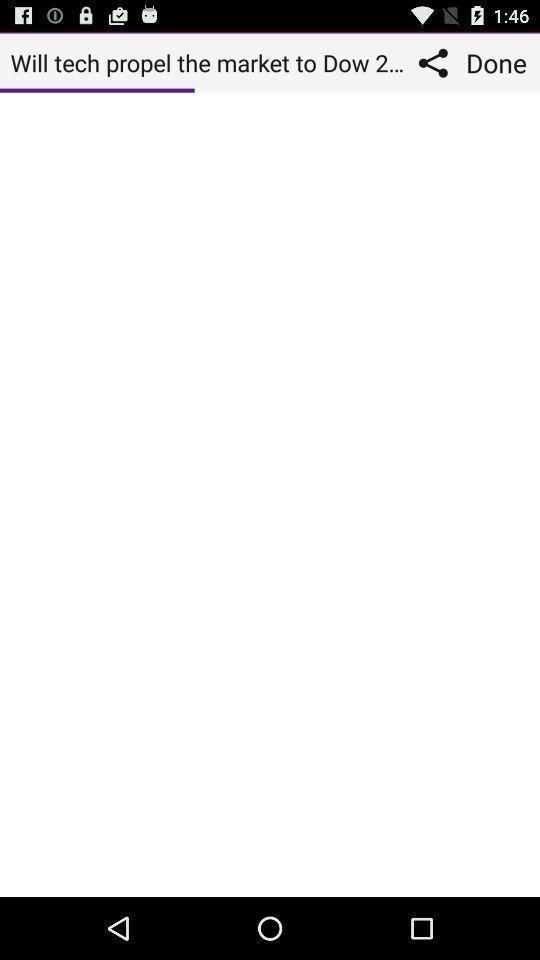What is the overall content of this screenshot? Screen shows loading status of a web page. 